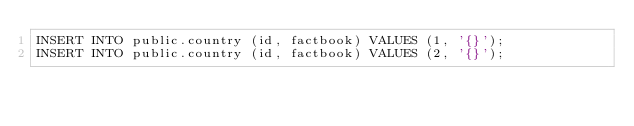Convert code to text. <code><loc_0><loc_0><loc_500><loc_500><_SQL_>INSERT INTO public.country (id, factbook) VALUES (1, '{}');
INSERT INTO public.country (id, factbook) VALUES (2, '{}');</code> 